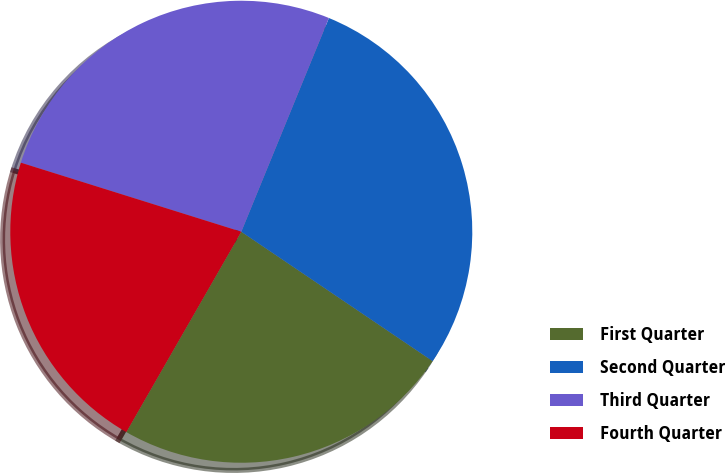Convert chart. <chart><loc_0><loc_0><loc_500><loc_500><pie_chart><fcel>First Quarter<fcel>Second Quarter<fcel>Third Quarter<fcel>Fourth Quarter<nl><fcel>23.83%<fcel>28.27%<fcel>26.36%<fcel>21.54%<nl></chart> 